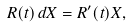<formula> <loc_0><loc_0><loc_500><loc_500>R ( t ) \, d X = R ^ { \prime } ( t ) X ,</formula> 